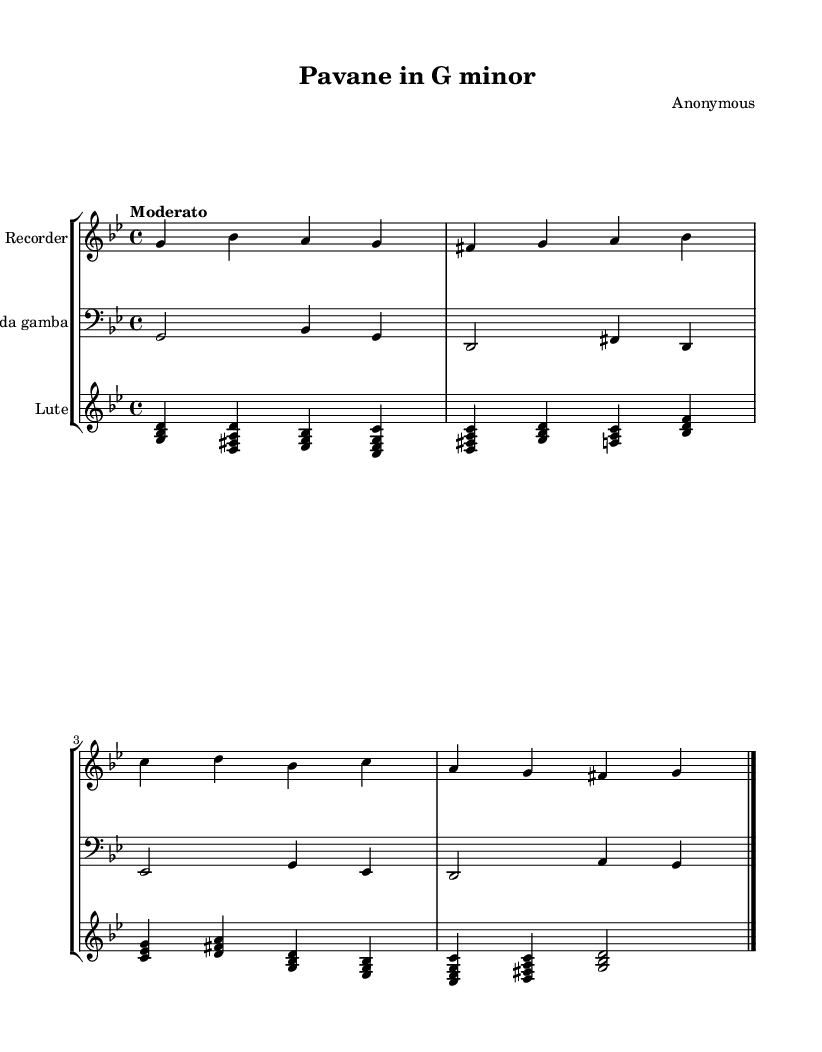What is the key signature of this music? The key signature has two flats (B♭ and E♭), indicating it is in G minor, which has the key signature of B♭ major.
Answer: G minor What is the time signature of this music? The time signature is indicated by the fraction at the beginning of the piece, which shows four beats per measure, represented as 4/4.
Answer: 4/4 What is the tempo marking given for this piece? The tempo marking is written above the staff and indicates the pace of the piece; it states "Moderato."
Answer: Moderato How many instruments are included in this score? By counting the different instrumental staffs present in the score, we can see three: Recorder, Viola da gamba, and Lute.
Answer: Three What genre does this piece belong to? The piece is a "Pavane," a slow dance genre typical of the Renaissance, which influenced early Baroque music.
Answer: Pavane What type of harmony is predominantly used in this piece? The score primarily employs triadic harmony, where chords are formed from three notes played together, characteristic of both Renaissance and Baroque music styles.
Answer: Triadic harmony What is the dynamic level indicated in this music? The dynamics are noted on the score and are generally marked, here there are no indications, so we assume a moderate volume without extremes.
Answer: Not specified 